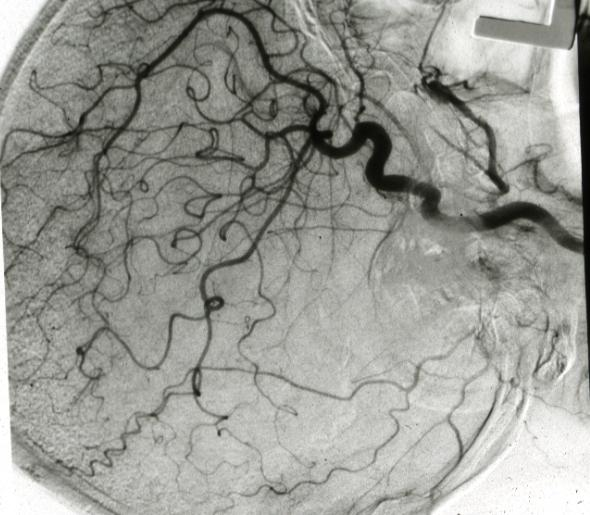s brain present?
Answer the question using a single word or phrase. Yes 